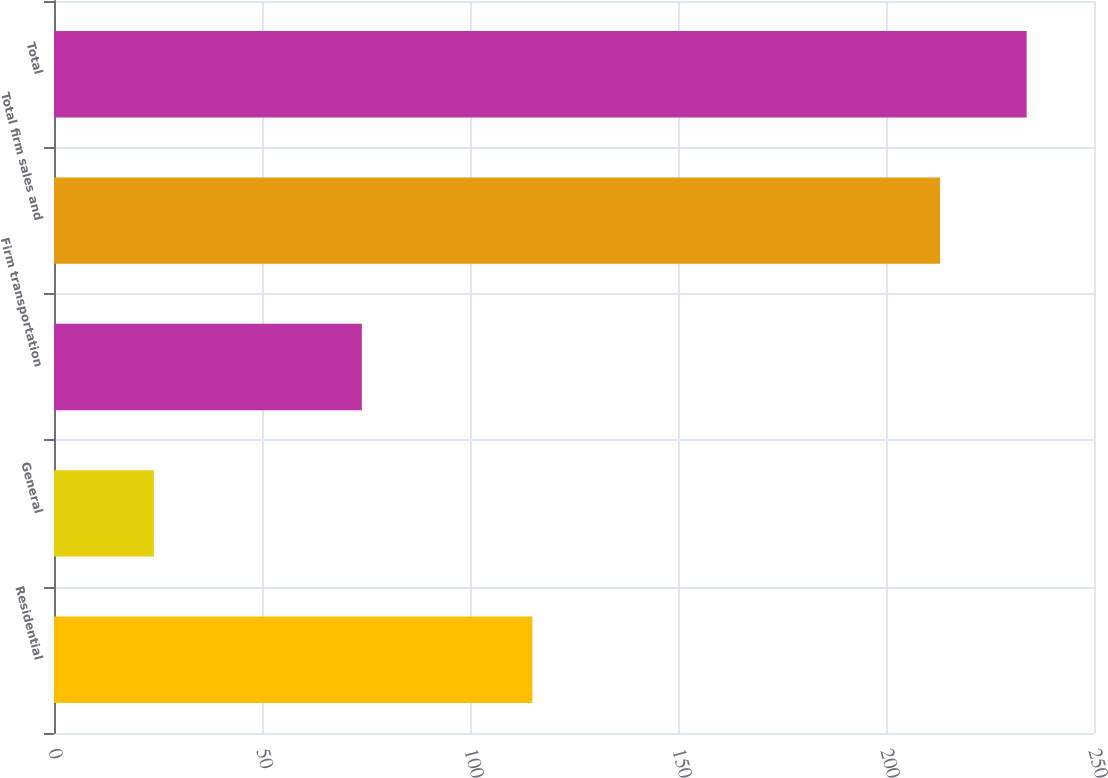Convert chart to OTSL. <chart><loc_0><loc_0><loc_500><loc_500><bar_chart><fcel>Residential<fcel>General<fcel>Firm transportation<fcel>Total firm sales and<fcel>Total<nl><fcel>115<fcel>24<fcel>74<fcel>213<fcel>233.8<nl></chart> 